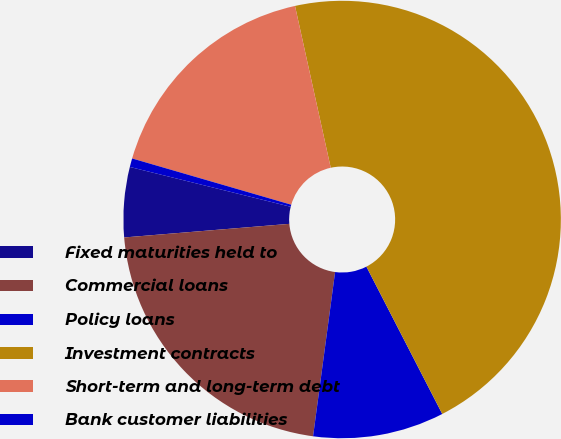Convert chart to OTSL. <chart><loc_0><loc_0><loc_500><loc_500><pie_chart><fcel>Fixed maturities held to<fcel>Commercial loans<fcel>Policy loans<fcel>Investment contracts<fcel>Short-term and long-term debt<fcel>Bank customer liabilities<nl><fcel>5.17%<fcel>21.57%<fcel>9.69%<fcel>45.89%<fcel>17.04%<fcel>0.64%<nl></chart> 